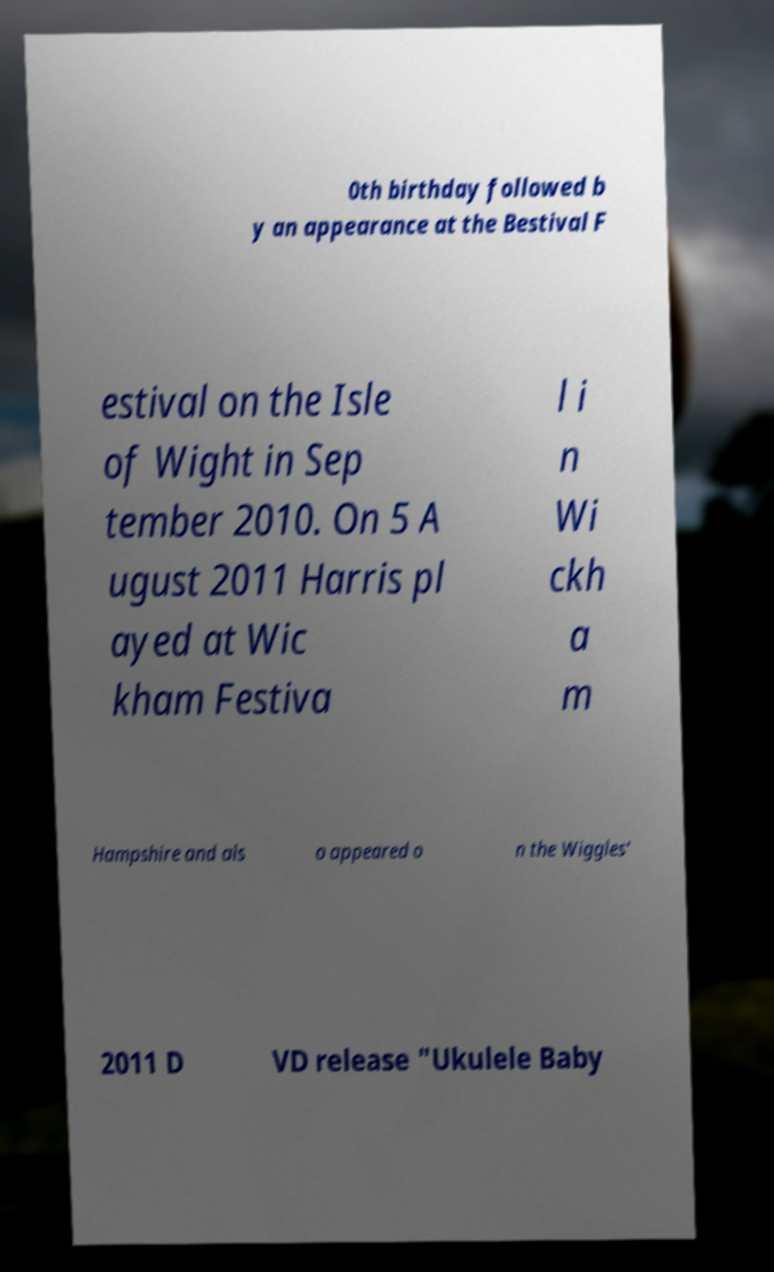Could you extract and type out the text from this image? 0th birthday followed b y an appearance at the Bestival F estival on the Isle of Wight in Sep tember 2010. On 5 A ugust 2011 Harris pl ayed at Wic kham Festiva l i n Wi ckh a m Hampshire and als o appeared o n the Wiggles' 2011 D VD release "Ukulele Baby 